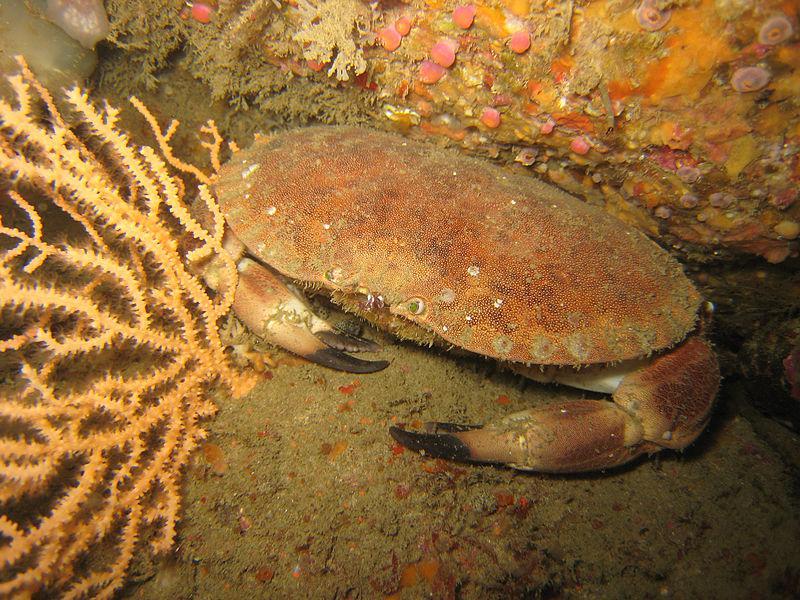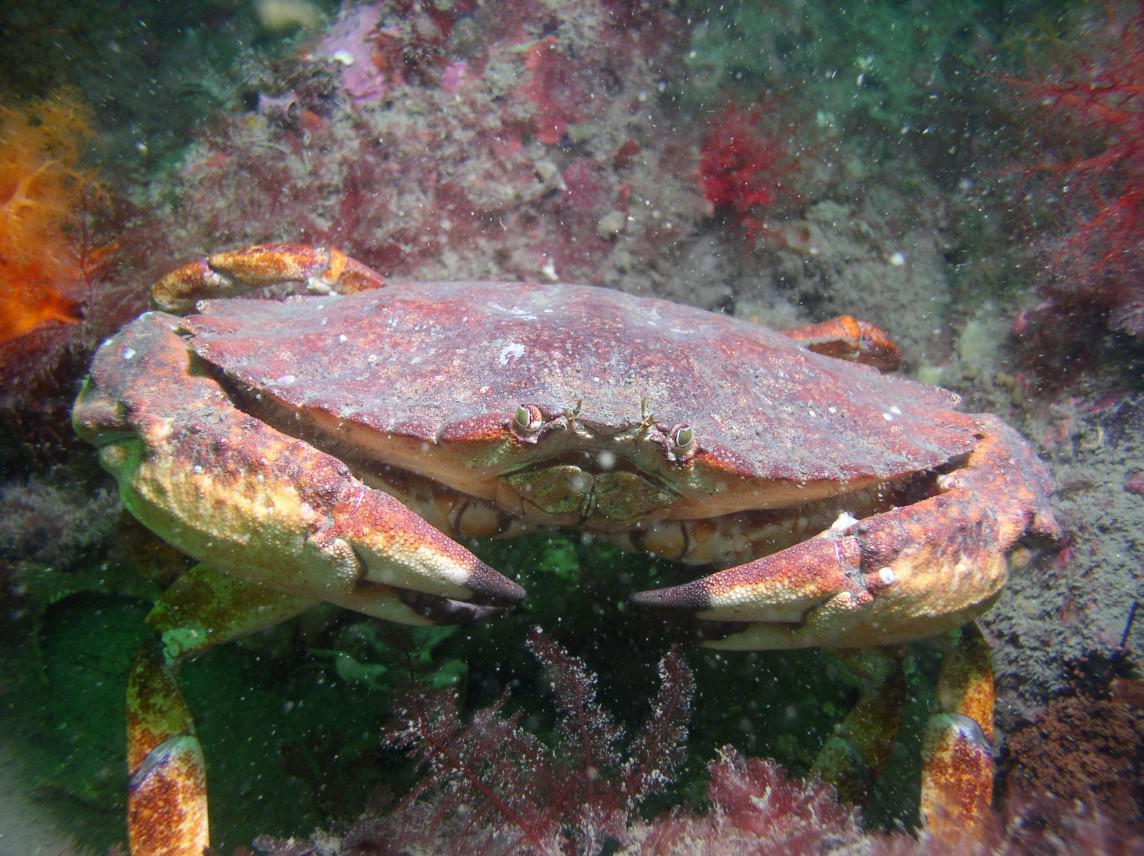The first image is the image on the left, the second image is the image on the right. For the images shown, is this caption "The right image is a top-view of a crab on dry sand, with its shell face-up and dotted with barnacles." true? Answer yes or no. No. The first image is the image on the left, the second image is the image on the right. Given the left and right images, does the statement "In at least one image there is a crab walking in the sand with at least 5 barnacles on top of the crab." hold true? Answer yes or no. No. 